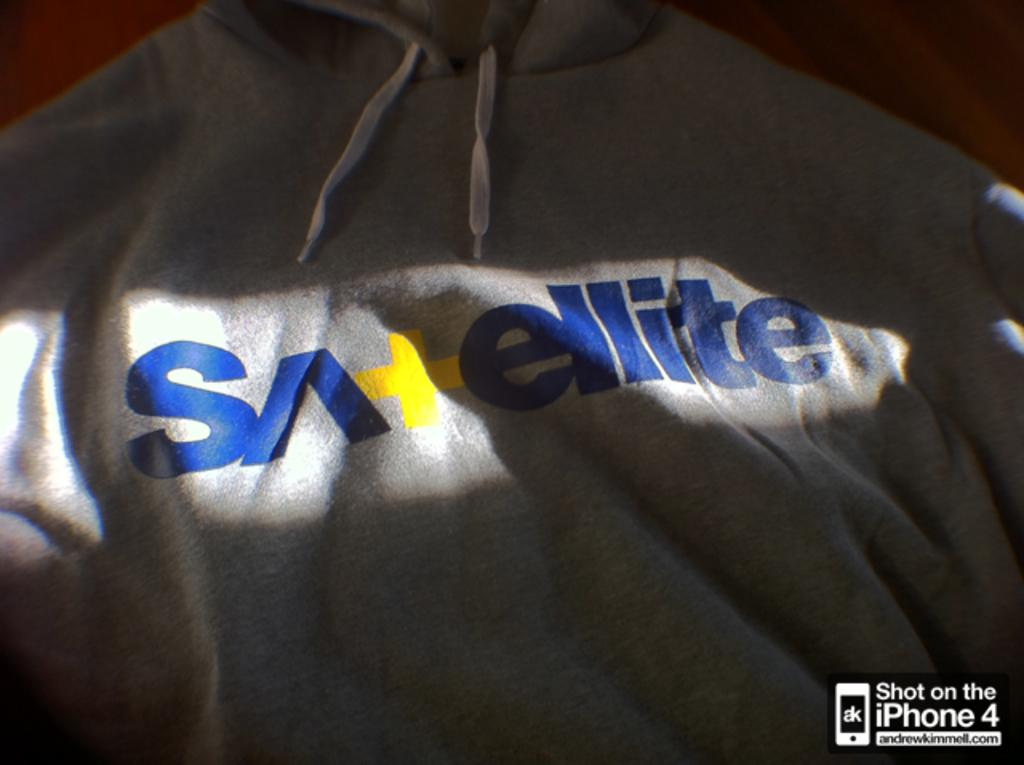Provide a one-sentence caption for the provided image. A hoodie that has sunlight shining on the word Satellite on it. 